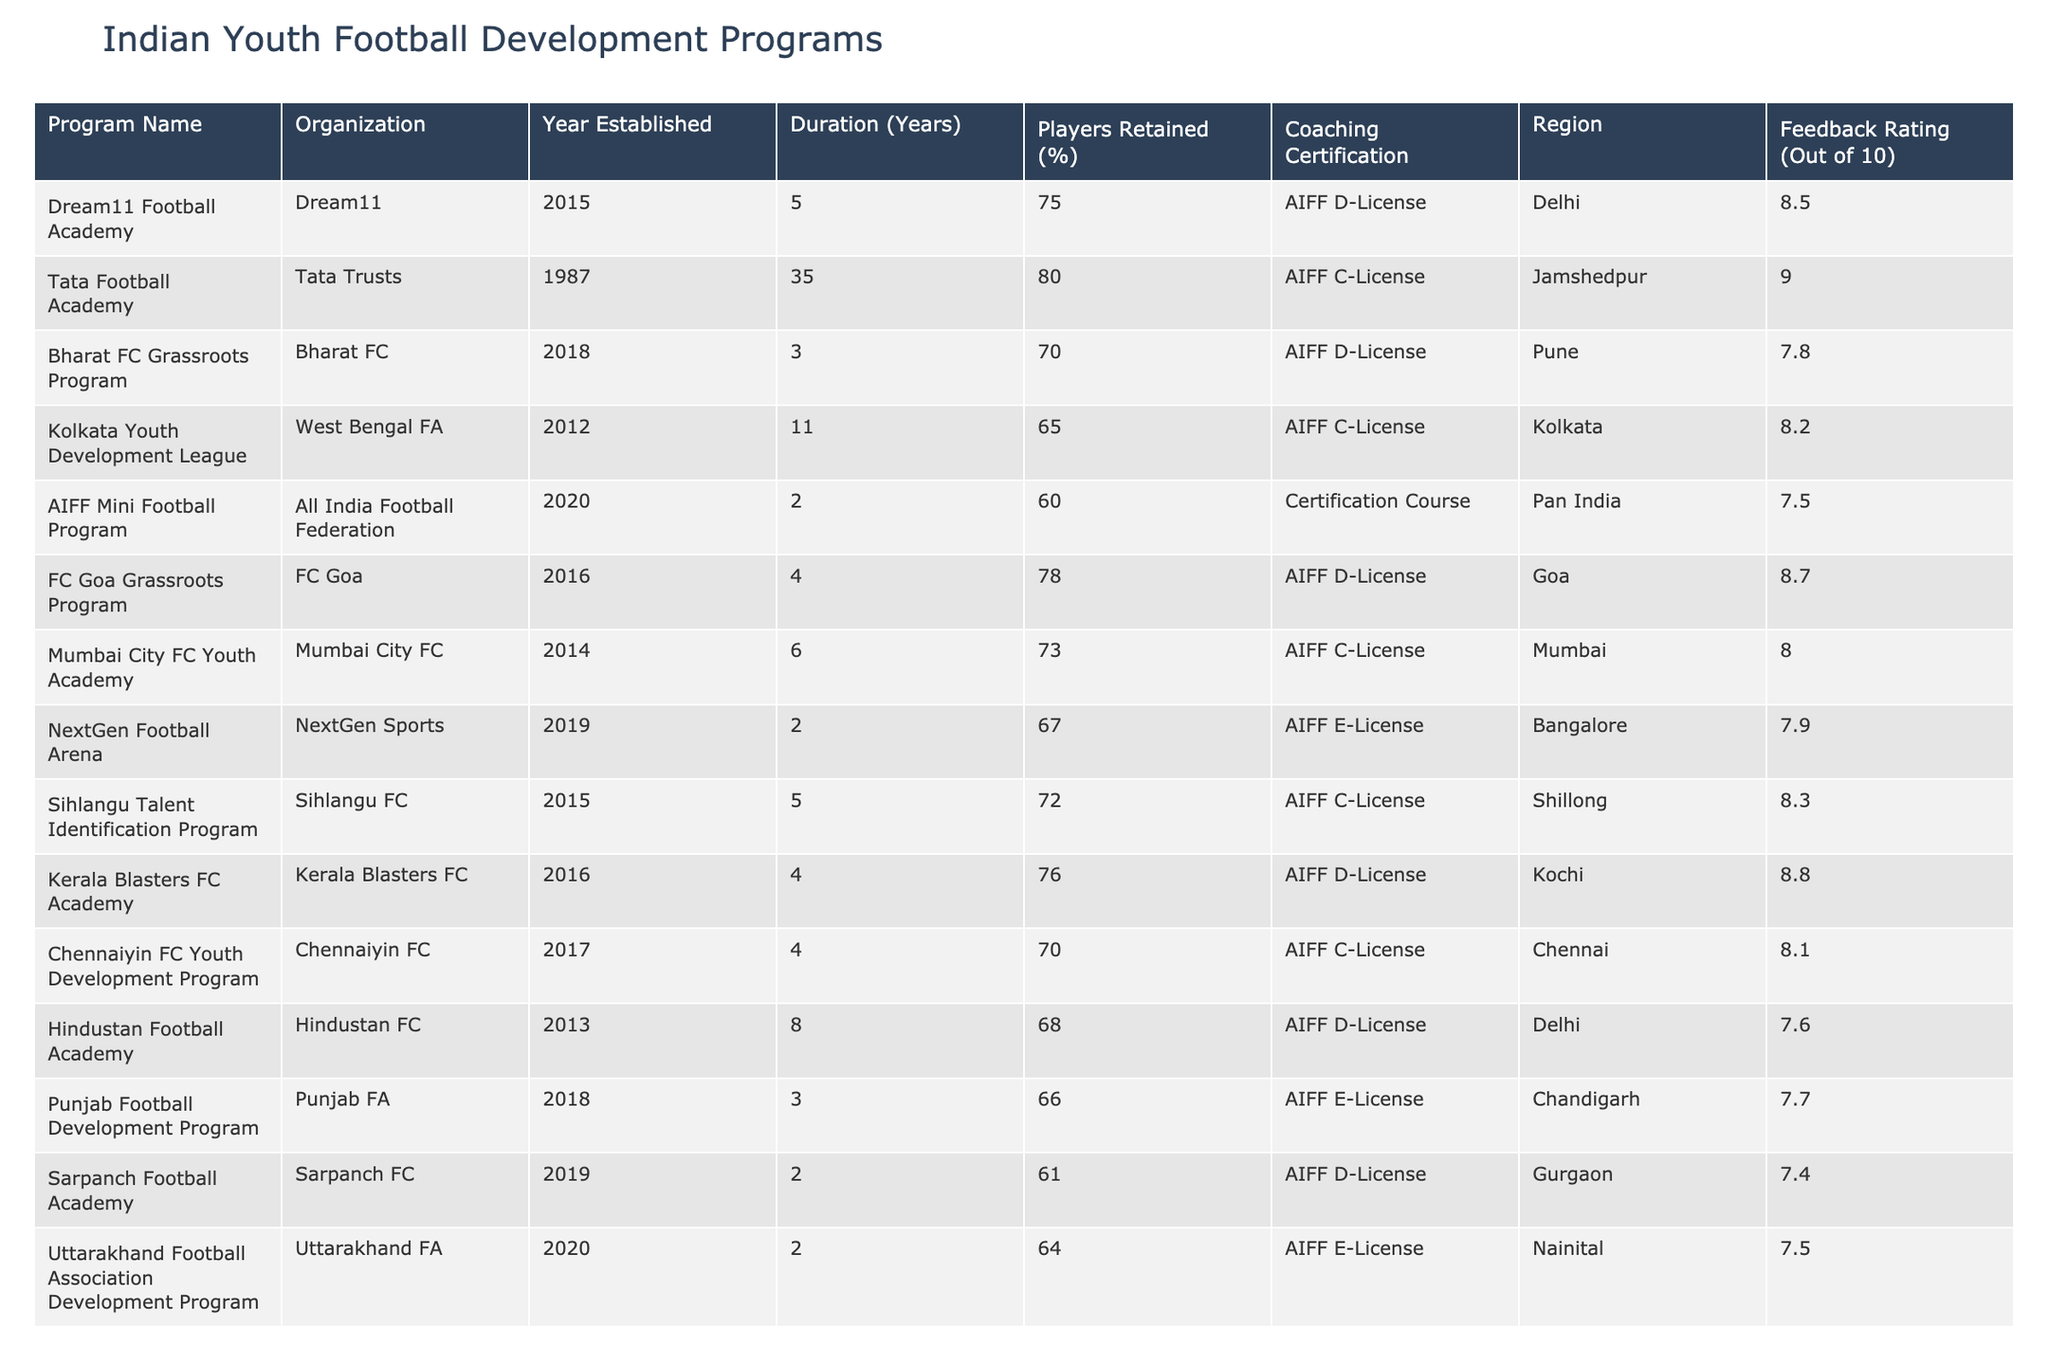What is the feedback rating of the Tata Football Academy? The feedback rating for the Tata Football Academy is listed in the table under the "Feedback Rating (Out of 10)" column. It shows a value of 9.0.
Answer: 9.0 Which program has the highest player retention percentage? By scanning the "Players Retained (%)" column, the Tata Football Academy has the highest percentage at 80%.
Answer: Tata Football Academy What is the average feedback rating for programs with an AIFF D-License? The programs with an AIFF D-License are Dream11 Football Academy, FC Goa Grassroots Program, Kerala Blasters FC Academy, Hindustan Football Academy, and Sarpanch Football Academy. Their feedback ratings are 8.5, 8.7, 8.8, 7.6, and 7.4 respectively. The average is (8.5 + 8.7 + 8.8 + 7.6 + 7.4) / 5 = 8.4.
Answer: 8.4 Is the duration of the Kolkata Youth Development League greater than the average duration of all programs? The duration of the Kolkata Youth Development League is 11 years. The average duration of all the programs can be calculated by summing the "Duration (Years)" column and dividing by the number of programs. The total duration is 5 + 35 + 3 + 11 + 2 + 4 + 6 + 2 + 5 + 4 + 4 + 8 + 3 + 2 =  3.6 years overall, leading to an average of 5.4 years (70 / 13). Since 11 > 5.4, the answer is yes.
Answer: Yes Which organization has established the AIFF Mini Football Program? The organization for the AIFF Mini Football Program is the All India Football Federation, as indicated clearly in the table under the "Organization" column.
Answer: All India Football Federation 